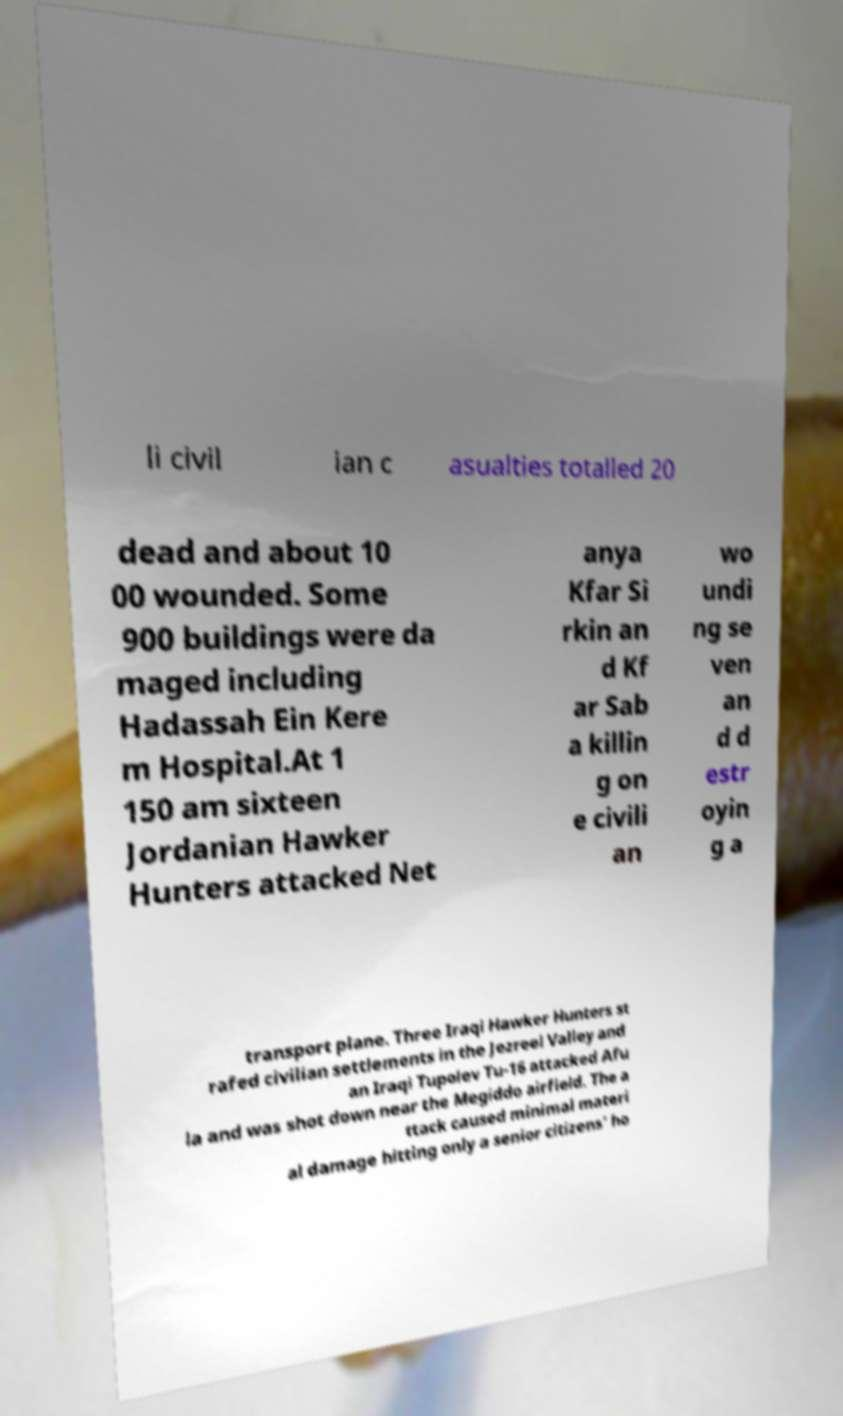Could you extract and type out the text from this image? li civil ian c asualties totalled 20 dead and about 10 00 wounded. Some 900 buildings were da maged including Hadassah Ein Kere m Hospital.At 1 150 am sixteen Jordanian Hawker Hunters attacked Net anya Kfar Si rkin an d Kf ar Sab a killin g on e civili an wo undi ng se ven an d d estr oyin g a transport plane. Three Iraqi Hawker Hunters st rafed civilian settlements in the Jezreel Valley and an Iraqi Tupolev Tu-16 attacked Afu la and was shot down near the Megiddo airfield. The a ttack caused minimal materi al damage hitting only a senior citizens' ho 